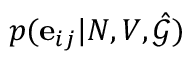Convert formula to latex. <formula><loc_0><loc_0><loc_500><loc_500>p ( e _ { i j } | N , V , \hat { \mathcal { G } } )</formula> 